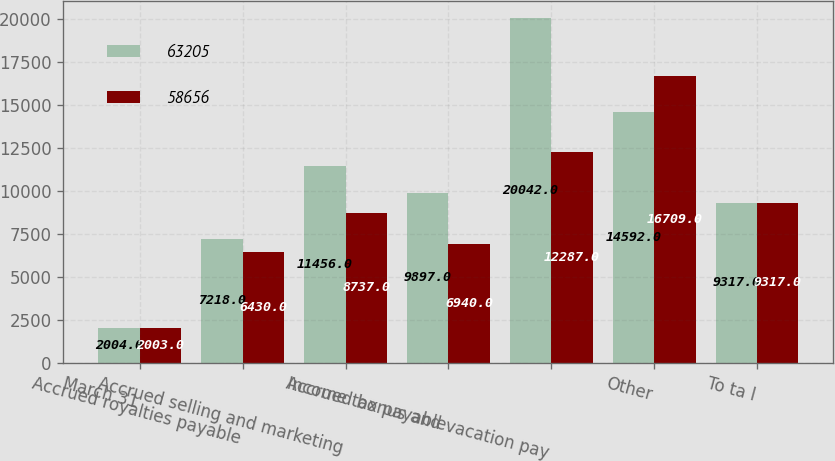<chart> <loc_0><loc_0><loc_500><loc_500><stacked_bar_chart><ecel><fcel>March 31<fcel>Accrued royalties payable<fcel>Accrued selling and marketing<fcel>Income tax payable<fcel>Accrued bonus and vacation pay<fcel>Other<fcel>To ta l<nl><fcel>63205<fcel>2004<fcel>7218<fcel>11456<fcel>9897<fcel>20042<fcel>14592<fcel>9317<nl><fcel>58656<fcel>2003<fcel>6430<fcel>8737<fcel>6940<fcel>12287<fcel>16709<fcel>9317<nl></chart> 